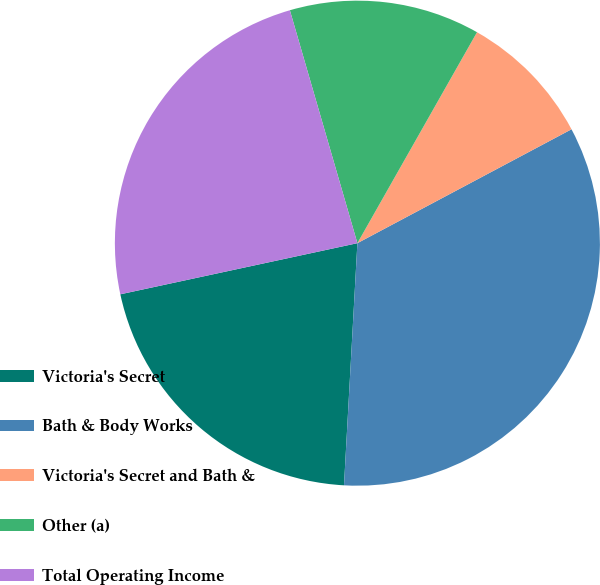Convert chart to OTSL. <chart><loc_0><loc_0><loc_500><loc_500><pie_chart><fcel>Victoria's Secret<fcel>Bath & Body Works<fcel>Victoria's Secret and Bath &<fcel>Other (a)<fcel>Total Operating Income<nl><fcel>20.74%<fcel>33.66%<fcel>9.01%<fcel>12.7%<fcel>23.89%<nl></chart> 